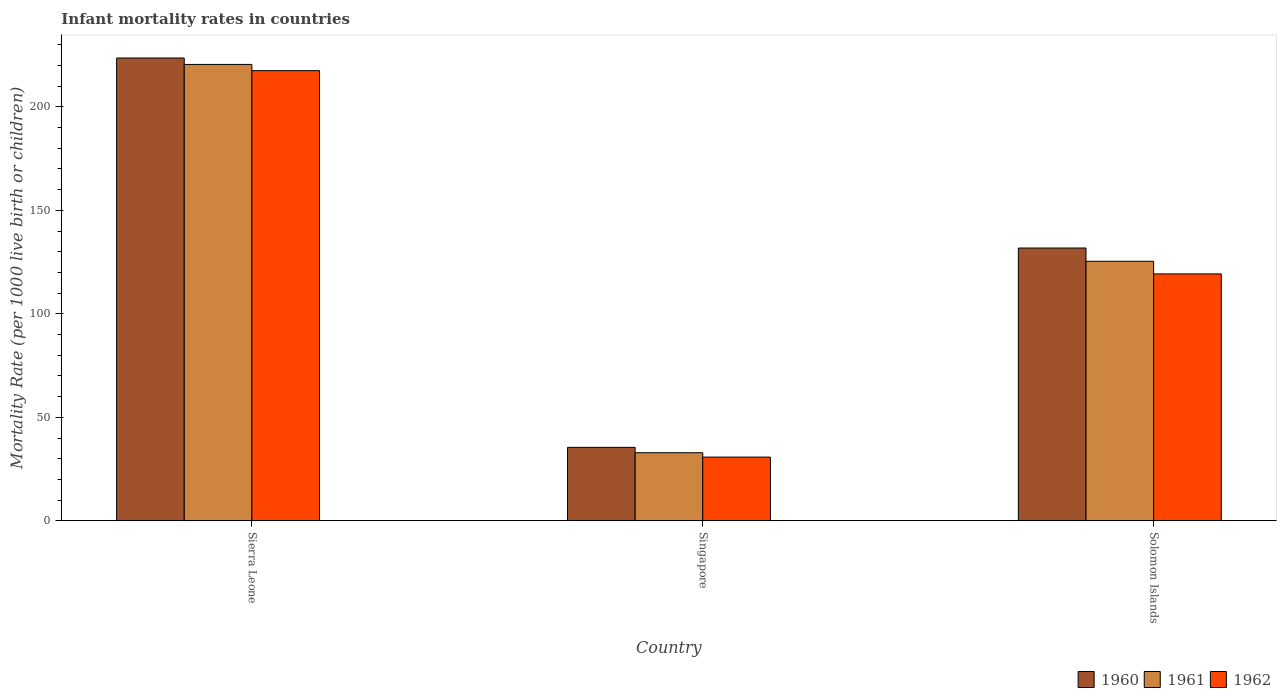How many different coloured bars are there?
Your answer should be very brief. 3. What is the label of the 1st group of bars from the left?
Offer a terse response. Sierra Leone. What is the infant mortality rate in 1961 in Singapore?
Make the answer very short. 32.9. Across all countries, what is the maximum infant mortality rate in 1960?
Your answer should be compact. 223.6. Across all countries, what is the minimum infant mortality rate in 1961?
Keep it short and to the point. 32.9. In which country was the infant mortality rate in 1962 maximum?
Ensure brevity in your answer.  Sierra Leone. In which country was the infant mortality rate in 1961 minimum?
Offer a very short reply. Singapore. What is the total infant mortality rate in 1962 in the graph?
Provide a short and direct response. 367.6. What is the difference between the infant mortality rate in 1962 in Singapore and that in Solomon Islands?
Ensure brevity in your answer.  -88.5. What is the difference between the infant mortality rate in 1960 in Sierra Leone and the infant mortality rate in 1961 in Singapore?
Ensure brevity in your answer.  190.7. What is the average infant mortality rate in 1960 per country?
Your answer should be very brief. 130.3. What is the difference between the infant mortality rate of/in 1960 and infant mortality rate of/in 1962 in Sierra Leone?
Keep it short and to the point. 6.1. What is the ratio of the infant mortality rate in 1960 in Sierra Leone to that in Singapore?
Keep it short and to the point. 6.3. Is the difference between the infant mortality rate in 1960 in Singapore and Solomon Islands greater than the difference between the infant mortality rate in 1962 in Singapore and Solomon Islands?
Offer a terse response. No. What is the difference between the highest and the second highest infant mortality rate in 1960?
Keep it short and to the point. -96.3. What is the difference between the highest and the lowest infant mortality rate in 1960?
Offer a terse response. 188.1. How many bars are there?
Offer a very short reply. 9. How many countries are there in the graph?
Offer a very short reply. 3. Are the values on the major ticks of Y-axis written in scientific E-notation?
Your response must be concise. No. Where does the legend appear in the graph?
Provide a short and direct response. Bottom right. How many legend labels are there?
Provide a short and direct response. 3. How are the legend labels stacked?
Offer a terse response. Horizontal. What is the title of the graph?
Offer a very short reply. Infant mortality rates in countries. Does "1990" appear as one of the legend labels in the graph?
Make the answer very short. No. What is the label or title of the X-axis?
Your answer should be very brief. Country. What is the label or title of the Y-axis?
Offer a terse response. Mortality Rate (per 1000 live birth or children). What is the Mortality Rate (per 1000 live birth or children) of 1960 in Sierra Leone?
Provide a short and direct response. 223.6. What is the Mortality Rate (per 1000 live birth or children) in 1961 in Sierra Leone?
Your response must be concise. 220.5. What is the Mortality Rate (per 1000 live birth or children) of 1962 in Sierra Leone?
Make the answer very short. 217.5. What is the Mortality Rate (per 1000 live birth or children) in 1960 in Singapore?
Offer a very short reply. 35.5. What is the Mortality Rate (per 1000 live birth or children) of 1961 in Singapore?
Offer a very short reply. 32.9. What is the Mortality Rate (per 1000 live birth or children) in 1962 in Singapore?
Offer a very short reply. 30.8. What is the Mortality Rate (per 1000 live birth or children) in 1960 in Solomon Islands?
Make the answer very short. 131.8. What is the Mortality Rate (per 1000 live birth or children) in 1961 in Solomon Islands?
Your answer should be compact. 125.4. What is the Mortality Rate (per 1000 live birth or children) in 1962 in Solomon Islands?
Provide a succinct answer. 119.3. Across all countries, what is the maximum Mortality Rate (per 1000 live birth or children) of 1960?
Give a very brief answer. 223.6. Across all countries, what is the maximum Mortality Rate (per 1000 live birth or children) of 1961?
Give a very brief answer. 220.5. Across all countries, what is the maximum Mortality Rate (per 1000 live birth or children) of 1962?
Your answer should be compact. 217.5. Across all countries, what is the minimum Mortality Rate (per 1000 live birth or children) of 1960?
Your answer should be compact. 35.5. Across all countries, what is the minimum Mortality Rate (per 1000 live birth or children) in 1961?
Offer a terse response. 32.9. Across all countries, what is the minimum Mortality Rate (per 1000 live birth or children) in 1962?
Your answer should be compact. 30.8. What is the total Mortality Rate (per 1000 live birth or children) in 1960 in the graph?
Your answer should be very brief. 390.9. What is the total Mortality Rate (per 1000 live birth or children) of 1961 in the graph?
Your answer should be compact. 378.8. What is the total Mortality Rate (per 1000 live birth or children) of 1962 in the graph?
Ensure brevity in your answer.  367.6. What is the difference between the Mortality Rate (per 1000 live birth or children) of 1960 in Sierra Leone and that in Singapore?
Ensure brevity in your answer.  188.1. What is the difference between the Mortality Rate (per 1000 live birth or children) of 1961 in Sierra Leone and that in Singapore?
Your response must be concise. 187.6. What is the difference between the Mortality Rate (per 1000 live birth or children) of 1962 in Sierra Leone and that in Singapore?
Give a very brief answer. 186.7. What is the difference between the Mortality Rate (per 1000 live birth or children) of 1960 in Sierra Leone and that in Solomon Islands?
Your answer should be very brief. 91.8. What is the difference between the Mortality Rate (per 1000 live birth or children) in 1961 in Sierra Leone and that in Solomon Islands?
Offer a terse response. 95.1. What is the difference between the Mortality Rate (per 1000 live birth or children) in 1962 in Sierra Leone and that in Solomon Islands?
Your answer should be compact. 98.2. What is the difference between the Mortality Rate (per 1000 live birth or children) in 1960 in Singapore and that in Solomon Islands?
Offer a terse response. -96.3. What is the difference between the Mortality Rate (per 1000 live birth or children) in 1961 in Singapore and that in Solomon Islands?
Offer a terse response. -92.5. What is the difference between the Mortality Rate (per 1000 live birth or children) in 1962 in Singapore and that in Solomon Islands?
Give a very brief answer. -88.5. What is the difference between the Mortality Rate (per 1000 live birth or children) in 1960 in Sierra Leone and the Mortality Rate (per 1000 live birth or children) in 1961 in Singapore?
Offer a very short reply. 190.7. What is the difference between the Mortality Rate (per 1000 live birth or children) in 1960 in Sierra Leone and the Mortality Rate (per 1000 live birth or children) in 1962 in Singapore?
Ensure brevity in your answer.  192.8. What is the difference between the Mortality Rate (per 1000 live birth or children) of 1961 in Sierra Leone and the Mortality Rate (per 1000 live birth or children) of 1962 in Singapore?
Your response must be concise. 189.7. What is the difference between the Mortality Rate (per 1000 live birth or children) in 1960 in Sierra Leone and the Mortality Rate (per 1000 live birth or children) in 1961 in Solomon Islands?
Your response must be concise. 98.2. What is the difference between the Mortality Rate (per 1000 live birth or children) in 1960 in Sierra Leone and the Mortality Rate (per 1000 live birth or children) in 1962 in Solomon Islands?
Your response must be concise. 104.3. What is the difference between the Mortality Rate (per 1000 live birth or children) of 1961 in Sierra Leone and the Mortality Rate (per 1000 live birth or children) of 1962 in Solomon Islands?
Offer a terse response. 101.2. What is the difference between the Mortality Rate (per 1000 live birth or children) of 1960 in Singapore and the Mortality Rate (per 1000 live birth or children) of 1961 in Solomon Islands?
Your response must be concise. -89.9. What is the difference between the Mortality Rate (per 1000 live birth or children) of 1960 in Singapore and the Mortality Rate (per 1000 live birth or children) of 1962 in Solomon Islands?
Make the answer very short. -83.8. What is the difference between the Mortality Rate (per 1000 live birth or children) of 1961 in Singapore and the Mortality Rate (per 1000 live birth or children) of 1962 in Solomon Islands?
Offer a very short reply. -86.4. What is the average Mortality Rate (per 1000 live birth or children) in 1960 per country?
Provide a short and direct response. 130.3. What is the average Mortality Rate (per 1000 live birth or children) of 1961 per country?
Provide a succinct answer. 126.27. What is the average Mortality Rate (per 1000 live birth or children) in 1962 per country?
Your answer should be compact. 122.53. What is the difference between the Mortality Rate (per 1000 live birth or children) in 1960 and Mortality Rate (per 1000 live birth or children) in 1961 in Sierra Leone?
Make the answer very short. 3.1. What is the difference between the Mortality Rate (per 1000 live birth or children) of 1961 and Mortality Rate (per 1000 live birth or children) of 1962 in Sierra Leone?
Provide a succinct answer. 3. What is the difference between the Mortality Rate (per 1000 live birth or children) in 1960 and Mortality Rate (per 1000 live birth or children) in 1961 in Singapore?
Provide a short and direct response. 2.6. What is the difference between the Mortality Rate (per 1000 live birth or children) in 1960 and Mortality Rate (per 1000 live birth or children) in 1961 in Solomon Islands?
Offer a very short reply. 6.4. What is the difference between the Mortality Rate (per 1000 live birth or children) in 1961 and Mortality Rate (per 1000 live birth or children) in 1962 in Solomon Islands?
Your answer should be compact. 6.1. What is the ratio of the Mortality Rate (per 1000 live birth or children) in 1960 in Sierra Leone to that in Singapore?
Make the answer very short. 6.3. What is the ratio of the Mortality Rate (per 1000 live birth or children) of 1961 in Sierra Leone to that in Singapore?
Provide a succinct answer. 6.7. What is the ratio of the Mortality Rate (per 1000 live birth or children) in 1962 in Sierra Leone to that in Singapore?
Your answer should be very brief. 7.06. What is the ratio of the Mortality Rate (per 1000 live birth or children) in 1960 in Sierra Leone to that in Solomon Islands?
Ensure brevity in your answer.  1.7. What is the ratio of the Mortality Rate (per 1000 live birth or children) in 1961 in Sierra Leone to that in Solomon Islands?
Make the answer very short. 1.76. What is the ratio of the Mortality Rate (per 1000 live birth or children) in 1962 in Sierra Leone to that in Solomon Islands?
Your answer should be very brief. 1.82. What is the ratio of the Mortality Rate (per 1000 live birth or children) of 1960 in Singapore to that in Solomon Islands?
Provide a short and direct response. 0.27. What is the ratio of the Mortality Rate (per 1000 live birth or children) of 1961 in Singapore to that in Solomon Islands?
Ensure brevity in your answer.  0.26. What is the ratio of the Mortality Rate (per 1000 live birth or children) in 1962 in Singapore to that in Solomon Islands?
Your answer should be compact. 0.26. What is the difference between the highest and the second highest Mortality Rate (per 1000 live birth or children) in 1960?
Ensure brevity in your answer.  91.8. What is the difference between the highest and the second highest Mortality Rate (per 1000 live birth or children) of 1961?
Give a very brief answer. 95.1. What is the difference between the highest and the second highest Mortality Rate (per 1000 live birth or children) in 1962?
Ensure brevity in your answer.  98.2. What is the difference between the highest and the lowest Mortality Rate (per 1000 live birth or children) of 1960?
Give a very brief answer. 188.1. What is the difference between the highest and the lowest Mortality Rate (per 1000 live birth or children) of 1961?
Provide a short and direct response. 187.6. What is the difference between the highest and the lowest Mortality Rate (per 1000 live birth or children) of 1962?
Your answer should be very brief. 186.7. 